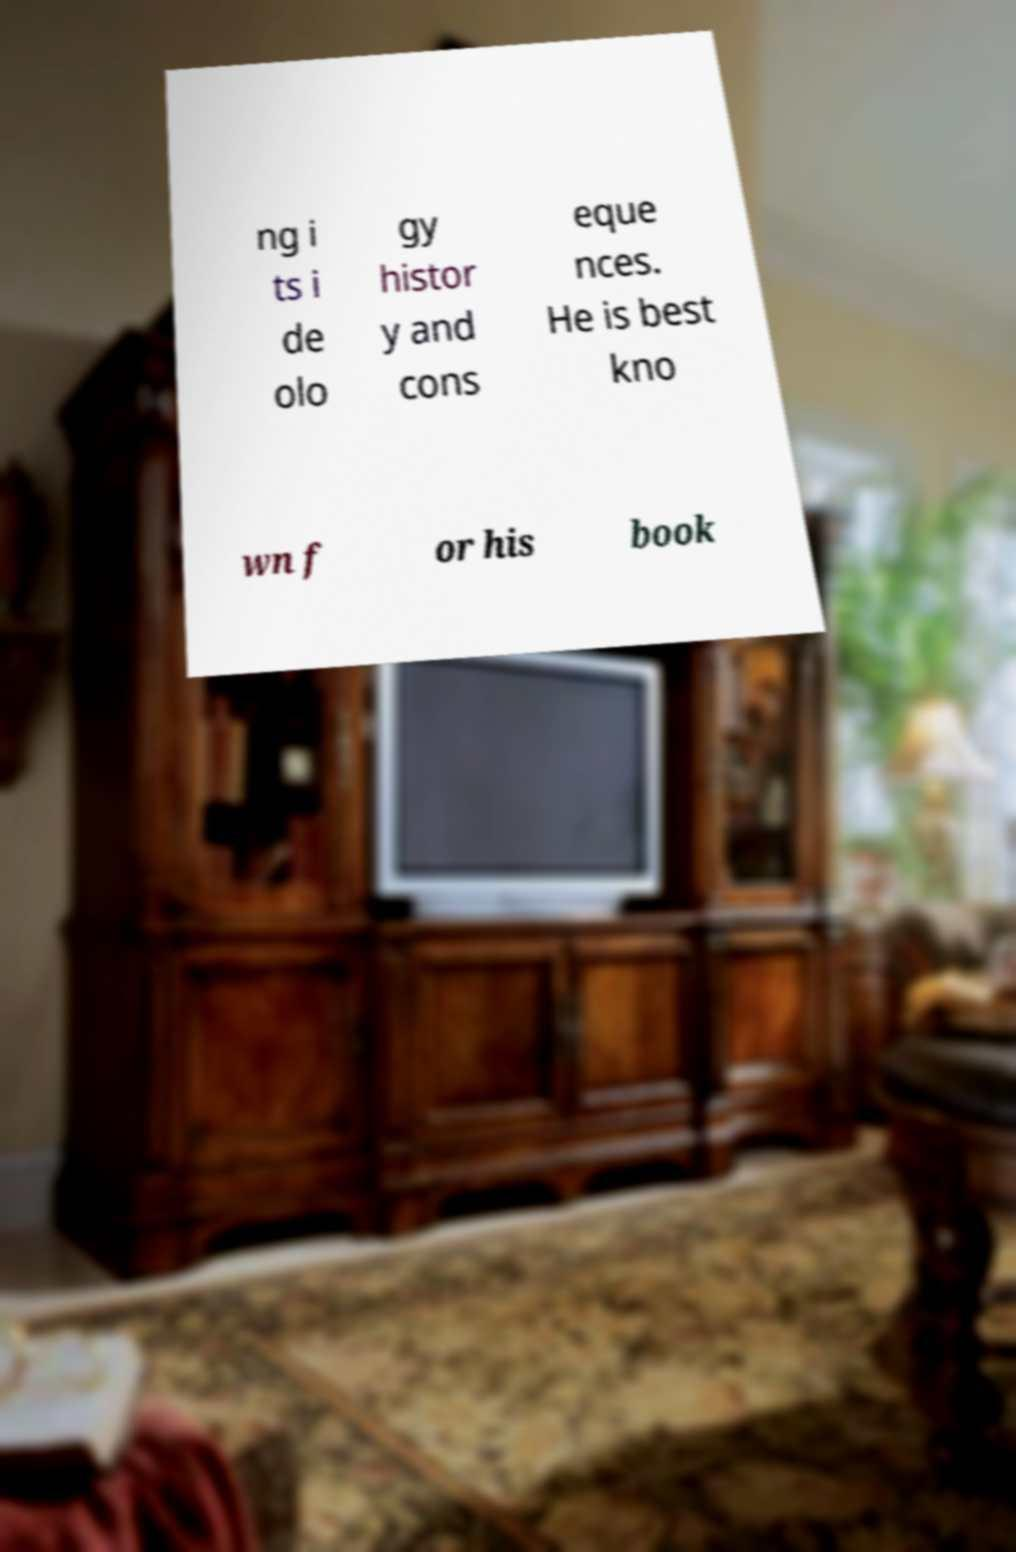I need the written content from this picture converted into text. Can you do that? ng i ts i de olo gy histor y and cons eque nces. He is best kno wn f or his book 